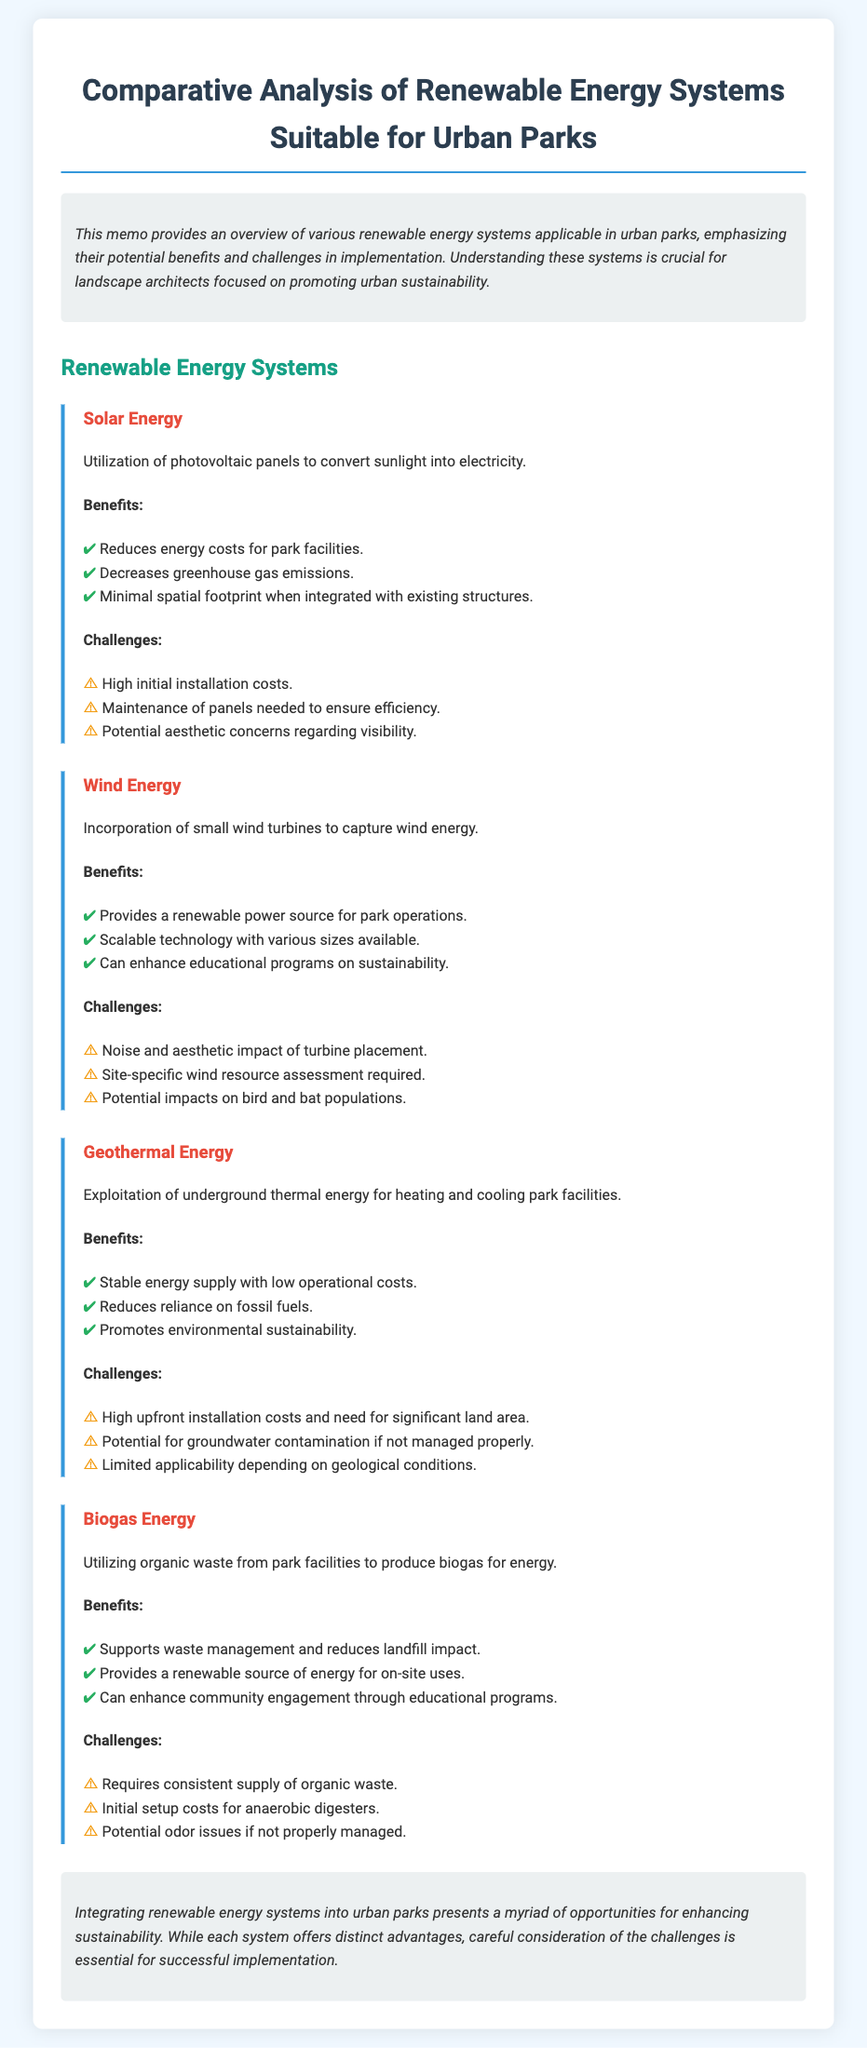What renewable energy system utilizes photovoltaic panels? The document states that solar energy systems utilize photovoltaic panels to convert sunlight into electricity.
Answer: Solar Energy What are two benefits of using wind energy systems in urban parks? The benefits listed for wind energy include providing a renewable power source for park operations and being a scalable technology with various sizes available.
Answer: Renewable power source, scalable technology What is a challenge specifically related to geothermal energy systems? The document mentions high upfront installation costs and the need for significant land area as challenges for geothermal energy systems.
Answer: High upfront installation costs How does biogas energy help with waste management? The memo indicates that biogas energy supports waste management and reduces landfill impact by utilizing organic waste from park facilities.
Answer: Supports waste management What is one potential aesthetic concern regarding solar energy systems? The document states that there are potential aesthetic concerns regarding the visibility of solar energy systems.
Answer: Visibility Which renewable energy system has the challenge of requiring a consistent supply of organic waste? The document highlights that biogas energy requires a consistent supply of organic waste for its operation.
Answer: Biogas Energy How many key benefits are listed for geothermal energy systems? The document enumerates three benefits of geothermal energy systems: stable energy supply, low operational costs, and reduced reliance on fossil fuels.
Answer: Three benefits What is one educational benefit mentioned in the document for wind energy systems? The memo notes that wind energy systems can enhance educational programs on sustainability as a benefit.
Answer: Enhance educational programs 